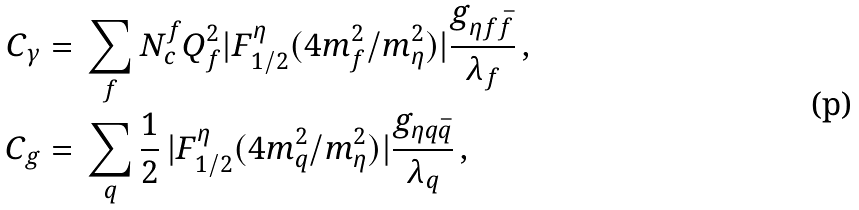<formula> <loc_0><loc_0><loc_500><loc_500>C _ { \gamma } & = \, \sum _ { f } N ^ { f } _ { c } Q _ { f } ^ { 2 } | F ^ { \eta } _ { 1 / 2 } ( 4 m _ { f } ^ { 2 } / m _ { \eta } ^ { 2 } ) | \frac { g _ { \eta f \bar { f } } } { \lambda _ { f } } \, , \\ C _ { g } & = \, \sum _ { q } \frac { 1 } { 2 } \, | F ^ { \eta } _ { 1 / 2 } ( 4 m _ { q } ^ { 2 } / m _ { \eta } ^ { 2 } ) | \frac { g _ { \eta q \bar { q } } } { \lambda _ { q } } \, ,</formula> 